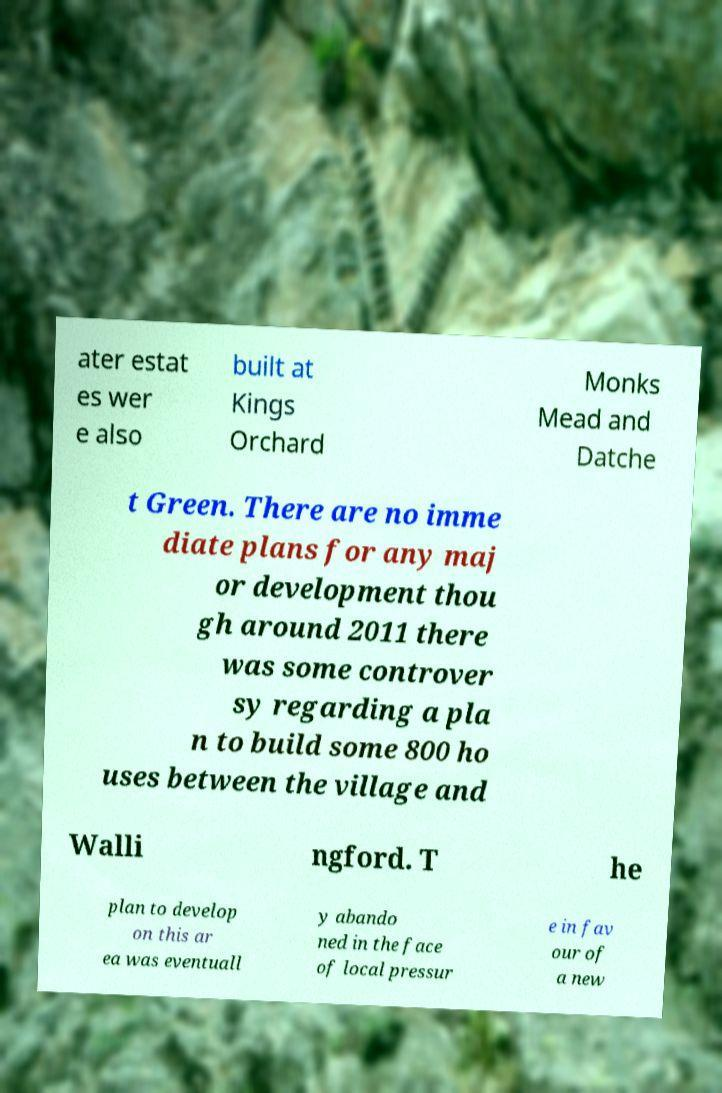Please read and relay the text visible in this image. What does it say? ater estat es wer e also built at Kings Orchard Monks Mead and Datche t Green. There are no imme diate plans for any maj or development thou gh around 2011 there was some controver sy regarding a pla n to build some 800 ho uses between the village and Walli ngford. T he plan to develop on this ar ea was eventuall y abando ned in the face of local pressur e in fav our of a new 